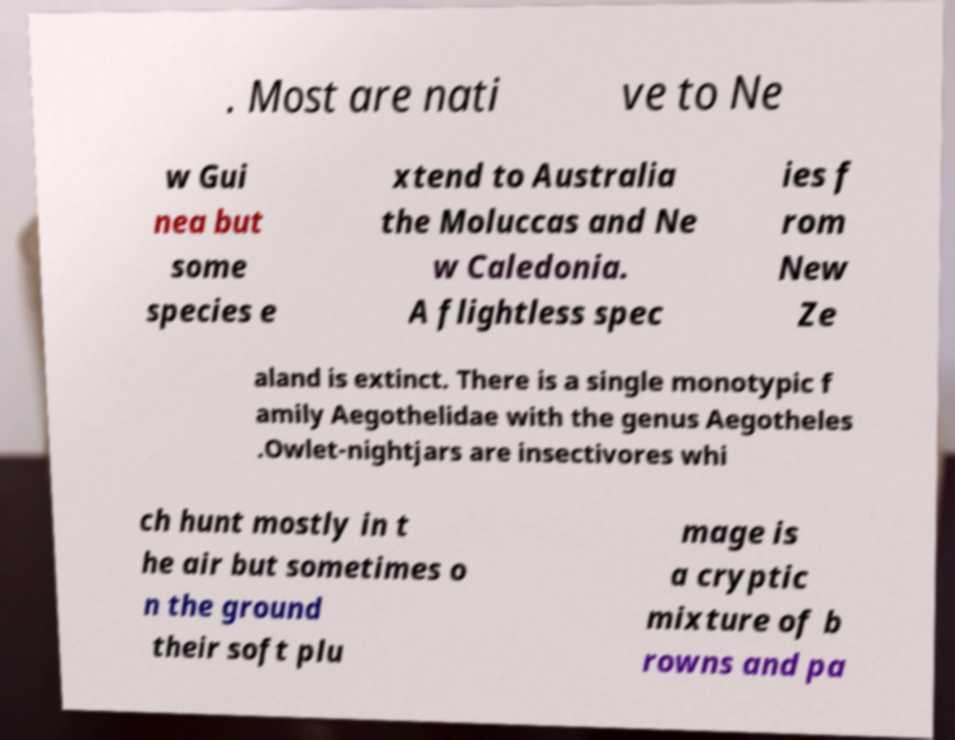I need the written content from this picture converted into text. Can you do that? . Most are nati ve to Ne w Gui nea but some species e xtend to Australia the Moluccas and Ne w Caledonia. A flightless spec ies f rom New Ze aland is extinct. There is a single monotypic f amily Aegothelidae with the genus Aegotheles .Owlet-nightjars are insectivores whi ch hunt mostly in t he air but sometimes o n the ground their soft plu mage is a cryptic mixture of b rowns and pa 